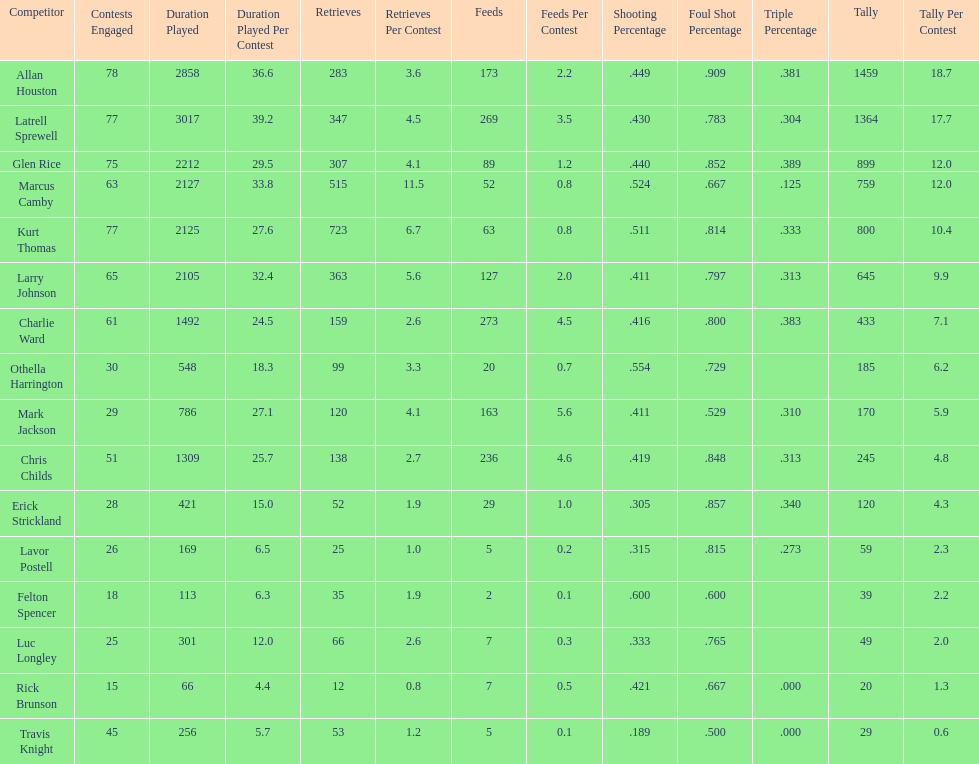How many games did larry johnson play? 65. 